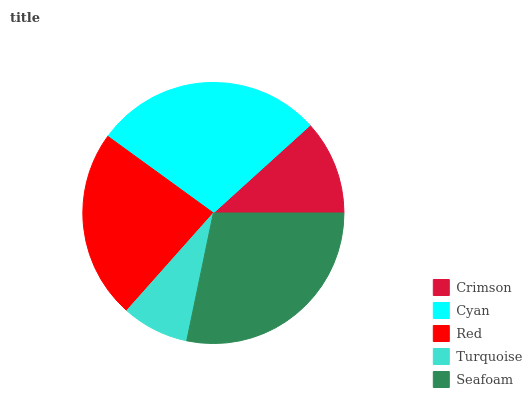Is Turquoise the minimum?
Answer yes or no. Yes. Is Cyan the maximum?
Answer yes or no. Yes. Is Red the minimum?
Answer yes or no. No. Is Red the maximum?
Answer yes or no. No. Is Cyan greater than Red?
Answer yes or no. Yes. Is Red less than Cyan?
Answer yes or no. Yes. Is Red greater than Cyan?
Answer yes or no. No. Is Cyan less than Red?
Answer yes or no. No. Is Red the high median?
Answer yes or no. Yes. Is Red the low median?
Answer yes or no. Yes. Is Cyan the high median?
Answer yes or no. No. Is Cyan the low median?
Answer yes or no. No. 